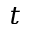Convert formula to latex. <formula><loc_0><loc_0><loc_500><loc_500>t</formula> 